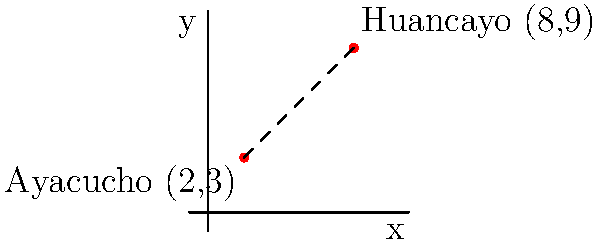During the internal conflict in Peru, two major cities affected were Ayacucho and Huancayo. On a coordinate plane, Ayacucho is located at (2,3) and Huancayo at (8,9). Calculate the straight-line distance between these two cities using the distance formula. To calculate the distance between two points, we use the distance formula:

$$ d = \sqrt{(x_2 - x_1)^2 + (y_2 - y_1)^2} $$

Where $(x_1, y_1)$ is the coordinate of Ayacucho (2,3) and $(x_2, y_2)$ is the coordinate of Huancayo (8,9).

Step 1: Identify the coordinates
Ayacucho: $(x_1, y_1) = (2, 3)$
Huancayo: $(x_2, y_2) = (8, 9)$

Step 2: Substitute the values into the formula
$$ d = \sqrt{(8 - 2)^2 + (9 - 3)^2} $$

Step 3: Calculate the differences
$$ d = \sqrt{6^2 + 6^2} $$

Step 4: Square the differences
$$ d = \sqrt{36 + 36} $$

Step 5: Add the squared differences
$$ d = \sqrt{72} $$

Step 6: Simplify the square root
$$ d = 6\sqrt{2} $$

Therefore, the straight-line distance between Ayacucho and Huancayo is $6\sqrt{2}$ units.
Answer: $6\sqrt{2}$ units 